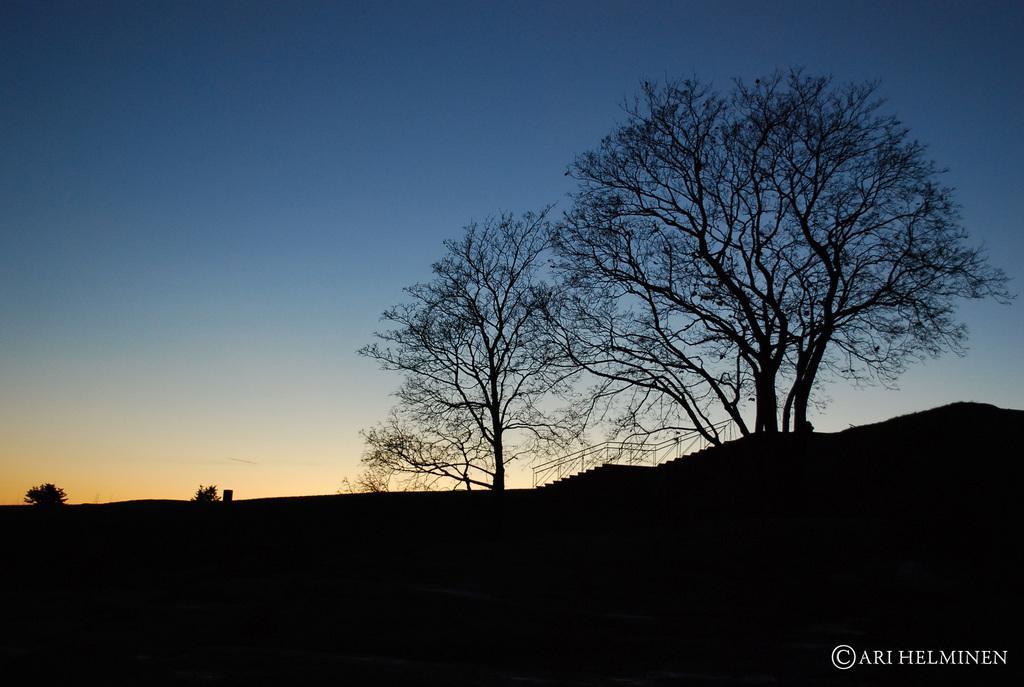Can you describe this image briefly? In the image there are trees on the land with steps on the right side and above its sky. 